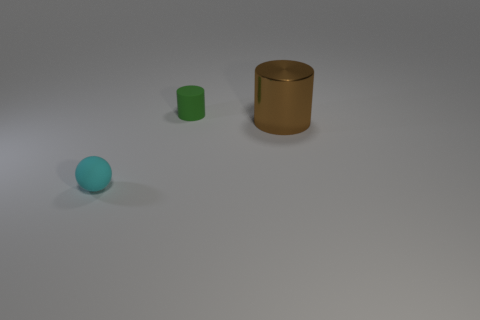Add 1 large blue metallic objects. How many objects exist? 4 Subtract all spheres. How many objects are left? 2 Subtract 0 red cylinders. How many objects are left? 3 Subtract all rubber things. Subtract all cyan matte objects. How many objects are left? 0 Add 2 shiny cylinders. How many shiny cylinders are left? 3 Add 1 matte cylinders. How many matte cylinders exist? 2 